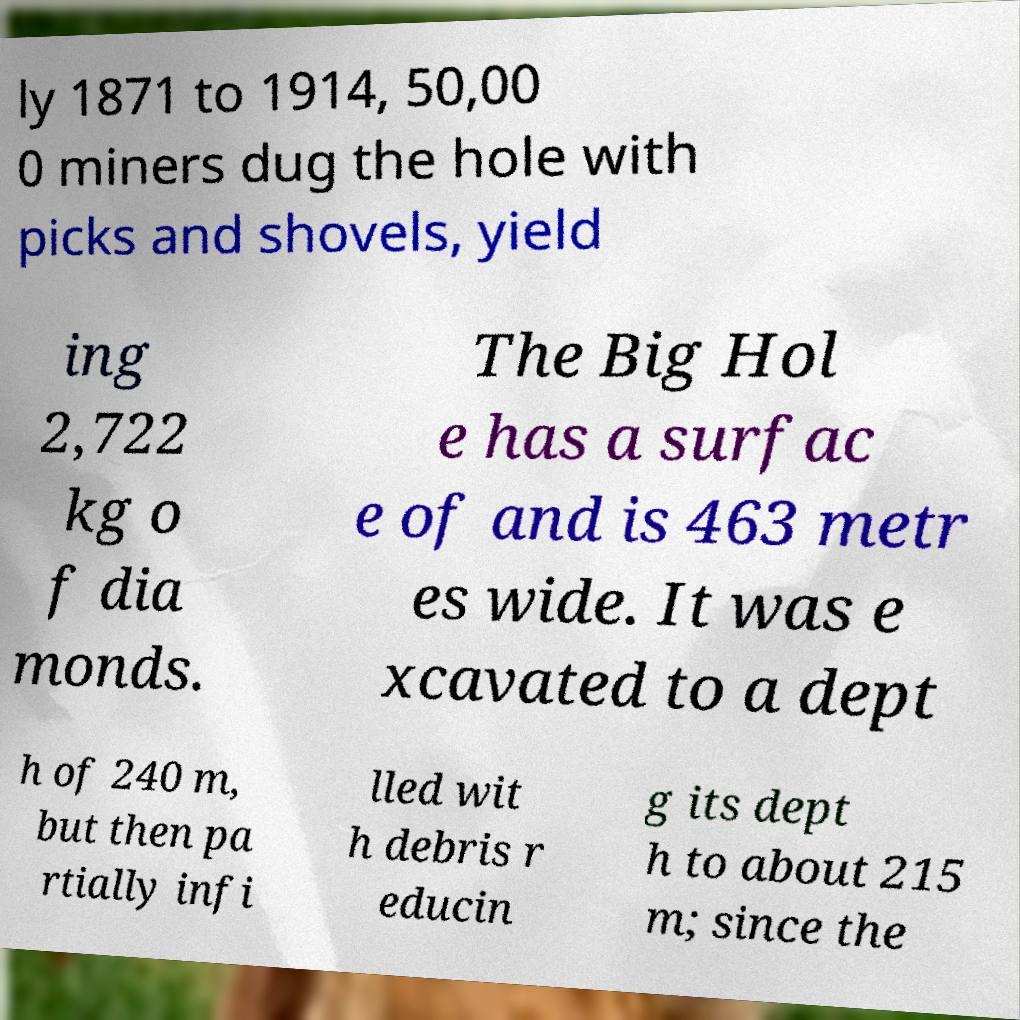For documentation purposes, I need the text within this image transcribed. Could you provide that? ly 1871 to 1914, 50,00 0 miners dug the hole with picks and shovels, yield ing 2,722 kg o f dia monds. The Big Hol e has a surfac e of and is 463 metr es wide. It was e xcavated to a dept h of 240 m, but then pa rtially infi lled wit h debris r educin g its dept h to about 215 m; since the 